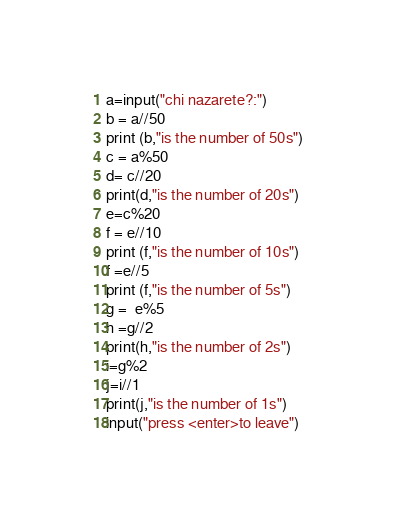<code> <loc_0><loc_0><loc_500><loc_500><_Python_>a=input("chi nazarete?:")
b = a//50
print (b,"is the number of 50s")
c = a%50
d= c//20
print(d,"is the number of 20s")
e=c%20
f = e//10
print (f,"is the number of 10s")
f =e//5
print (f,"is the number of 5s")
g =  e%5
h =g//2
print(h,"is the number of 2s")
i=g%2
j=i//1
print(j,"is the number of 1s")
input("press <enter>to leave")


</code> 